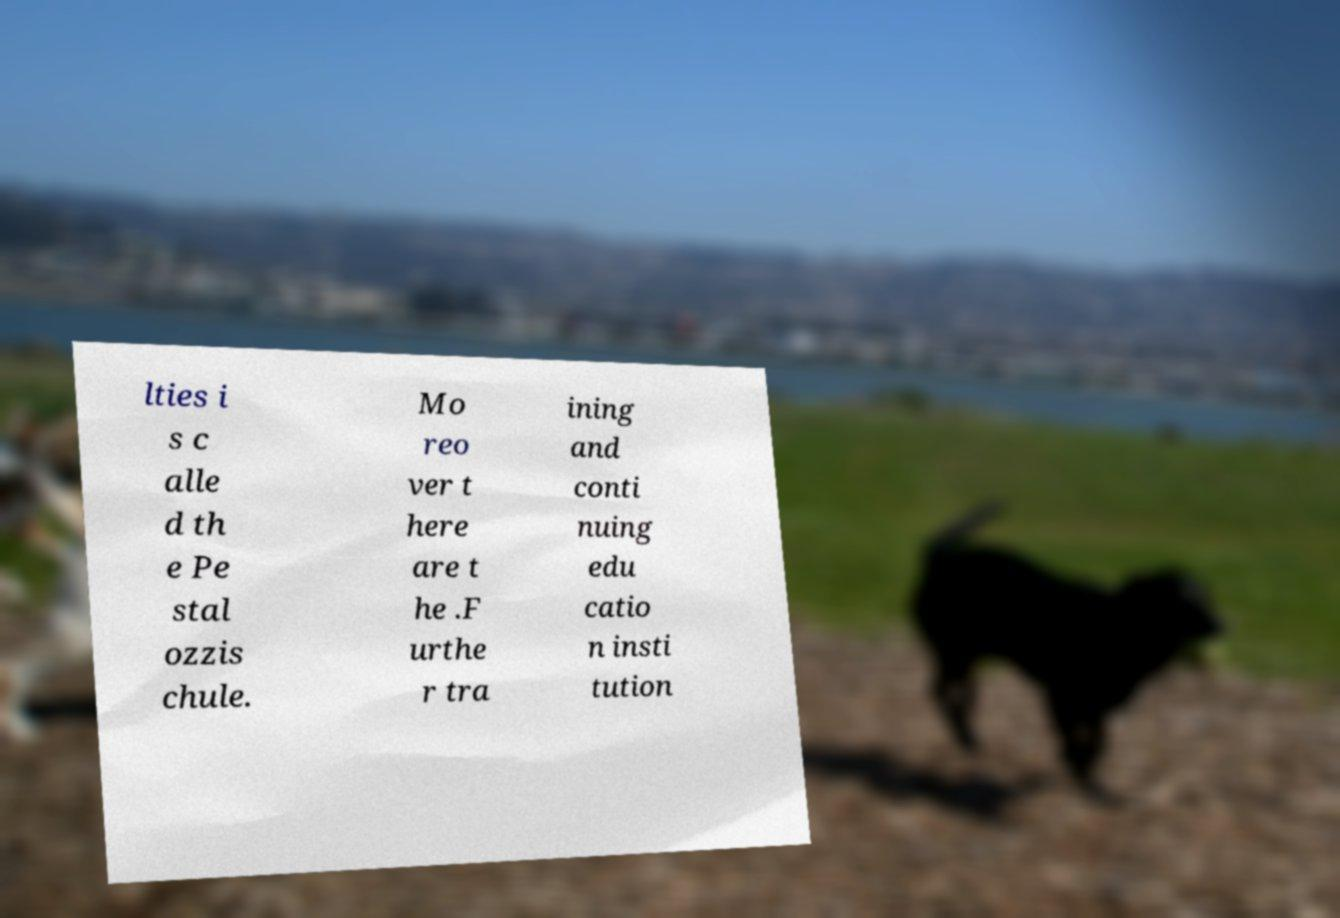There's text embedded in this image that I need extracted. Can you transcribe it verbatim? lties i s c alle d th e Pe stal ozzis chule. Mo reo ver t here are t he .F urthe r tra ining and conti nuing edu catio n insti tution 